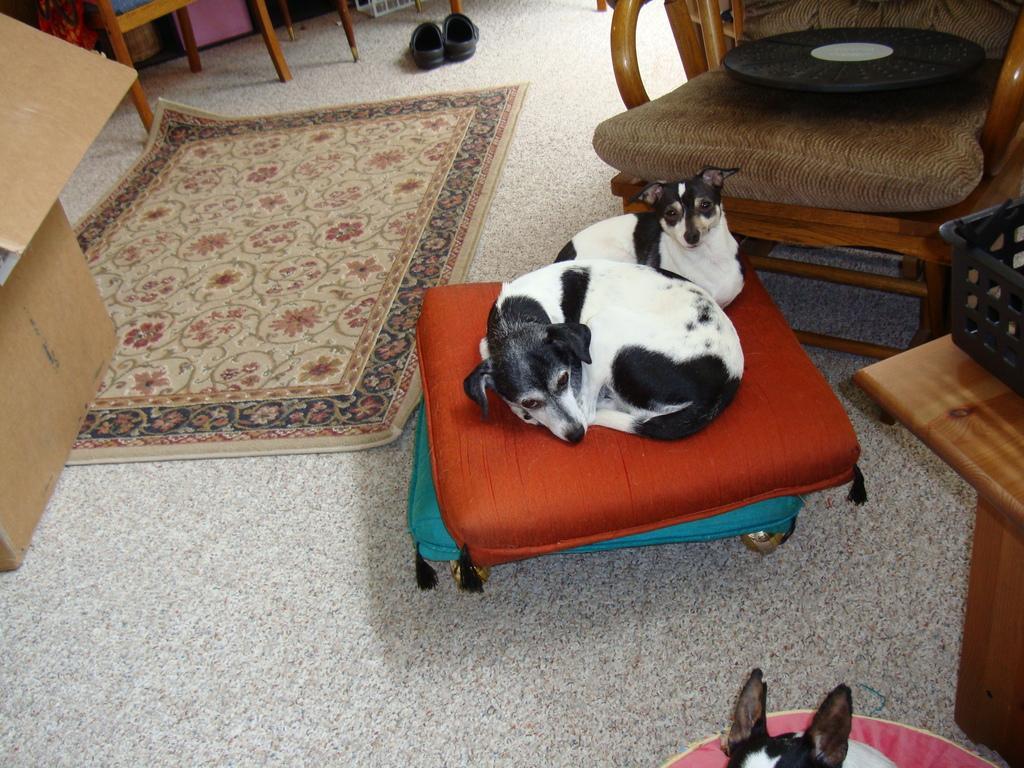Can you describe this image briefly? In the image we can see there are cushions on which the two dogs are sitting and the dogs are in black and white colour and behind them there is a chair and beside the chair there is a door mat. 